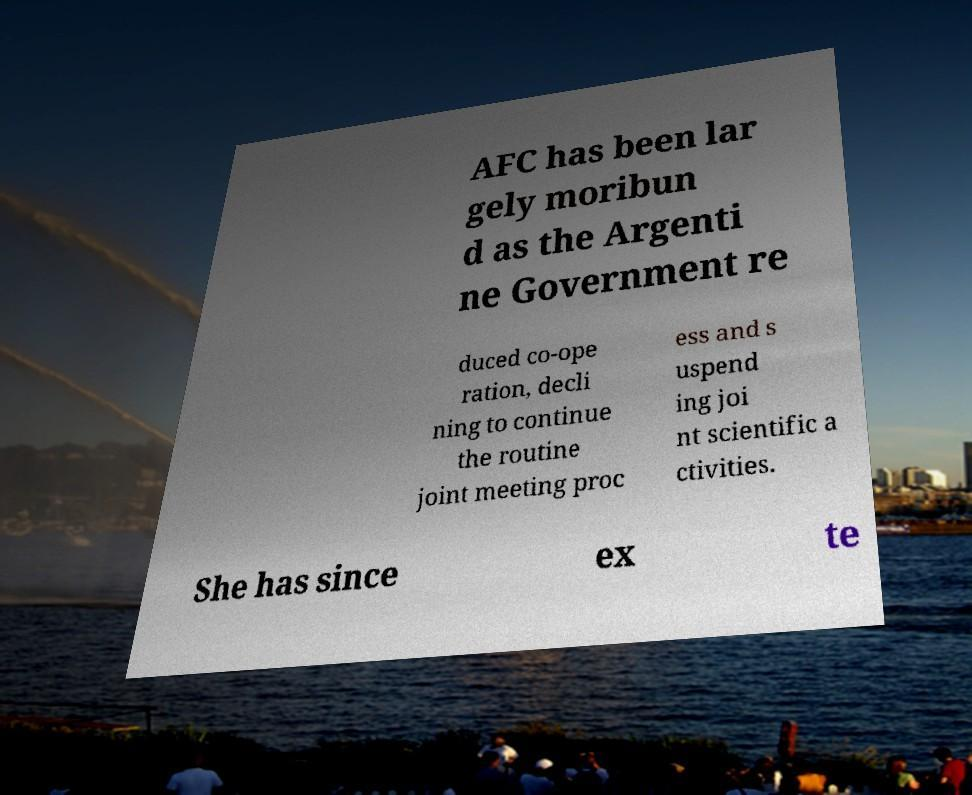For documentation purposes, I need the text within this image transcribed. Could you provide that? AFC has been lar gely moribun d as the Argenti ne Government re duced co-ope ration, decli ning to continue the routine joint meeting proc ess and s uspend ing joi nt scientific a ctivities. She has since ex te 